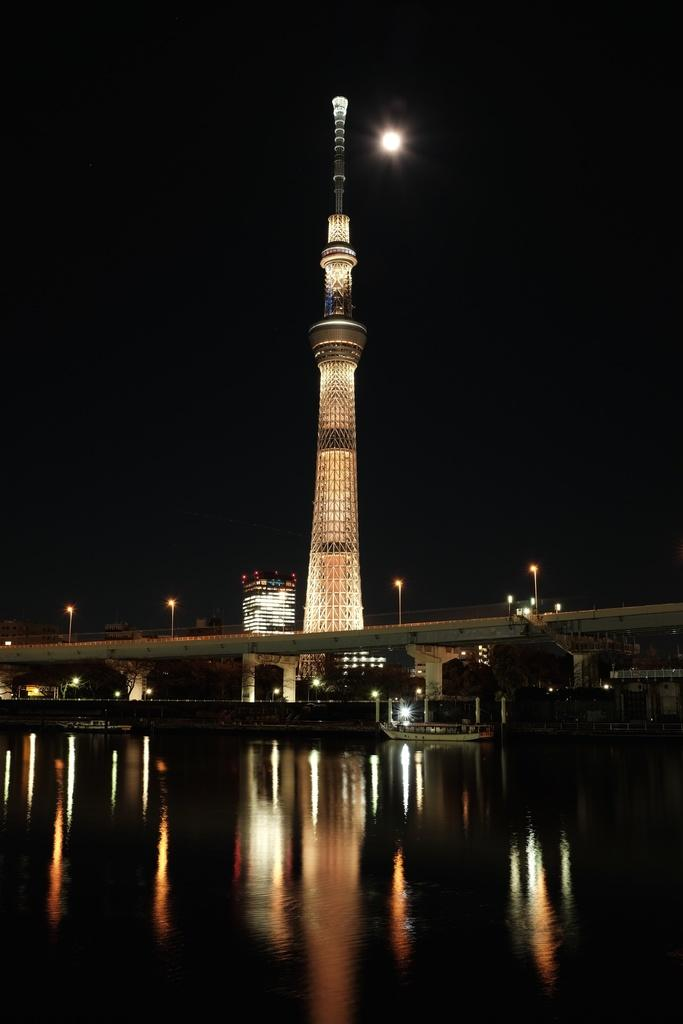What type of structures are illuminated in the image? There are buildings with lights in the image. What kind of infrastructure is present in the image? There is a bridge in the image. What type of lighting is present along the roads or paths in the image? There are street lights in the image. What type of watercraft can be seen in the image? There is a boat on the water in the image. What celestial body is visible in the sky in the image? There is a moon visible in the sky. How many chains are used to secure the boat in the image? There is no mention of chains in the image; the boat is on the water without any visible chains. What type of look does the bridge have in the image? The image does not describe the appearance or style of the bridge; it only mentions the presence of a bridge. 